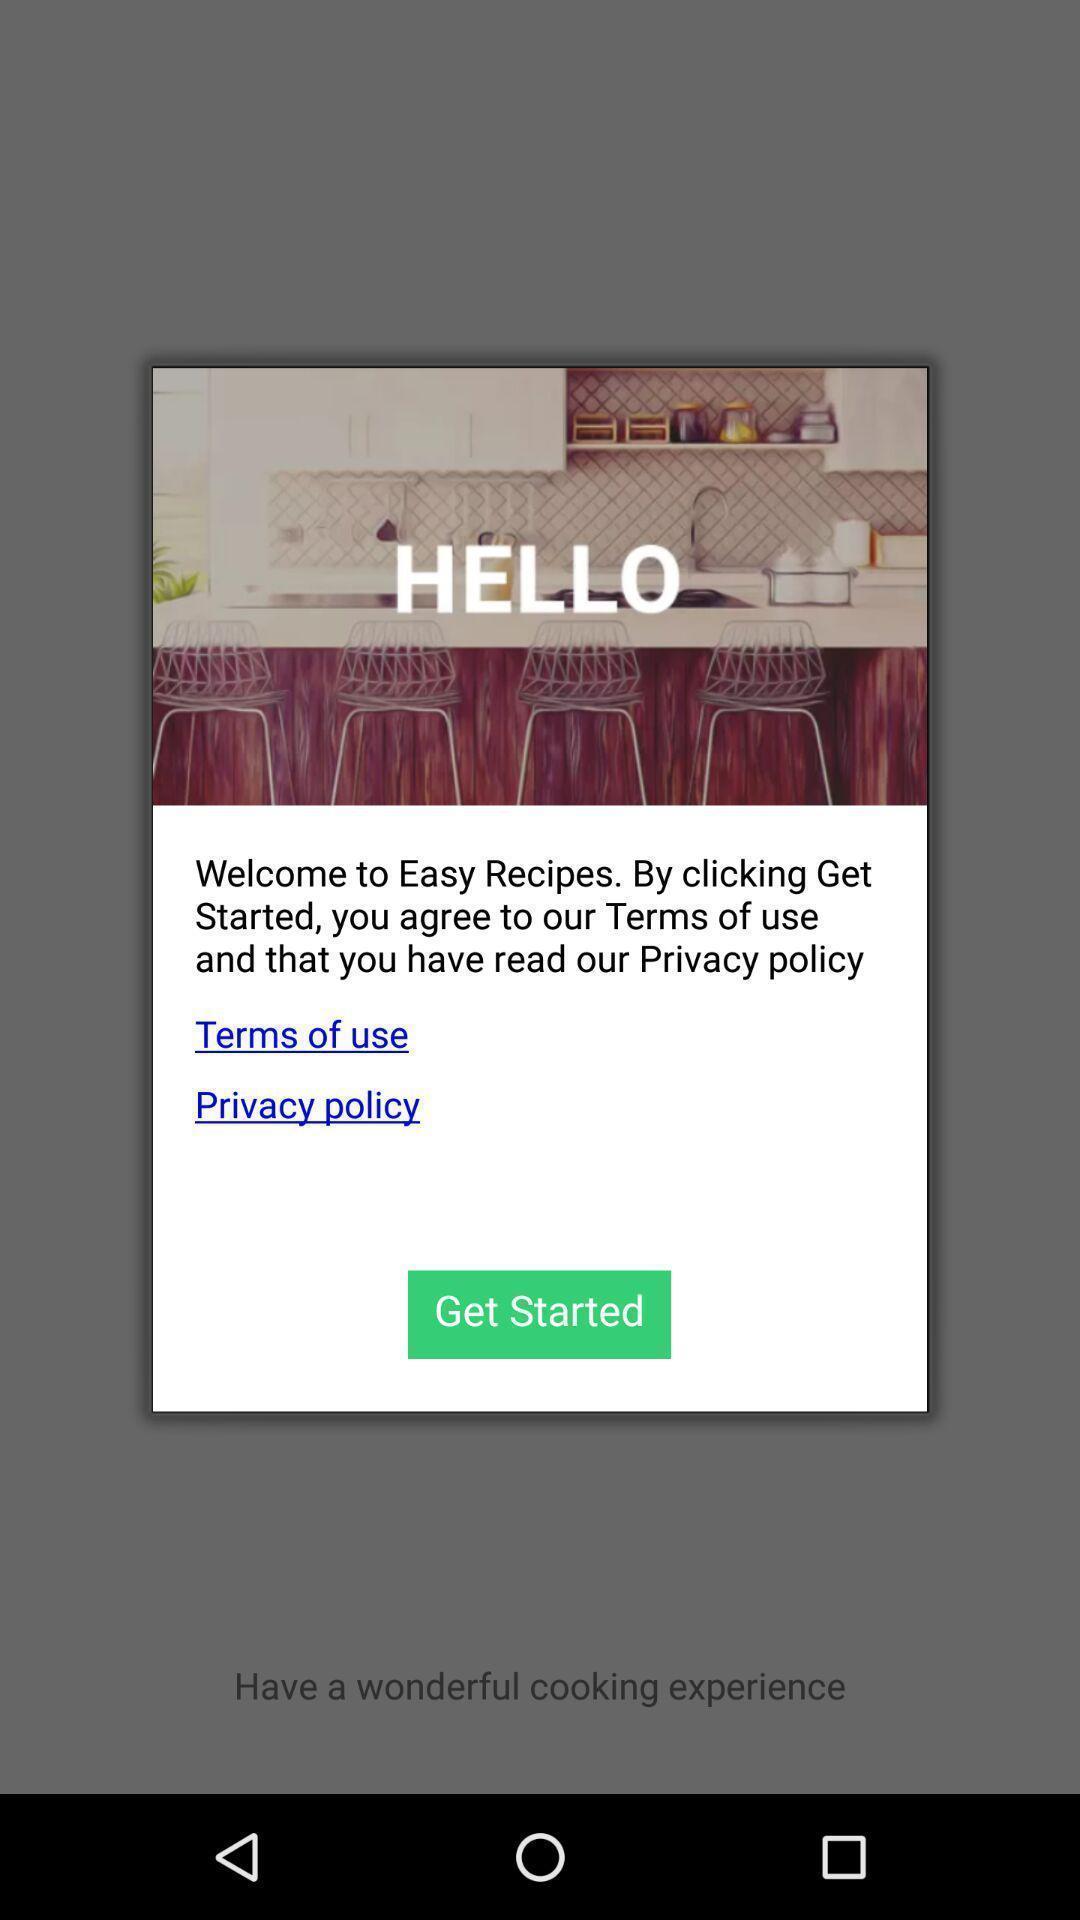What can you discern from this picture? Pop-up for the food application and with get started button. 